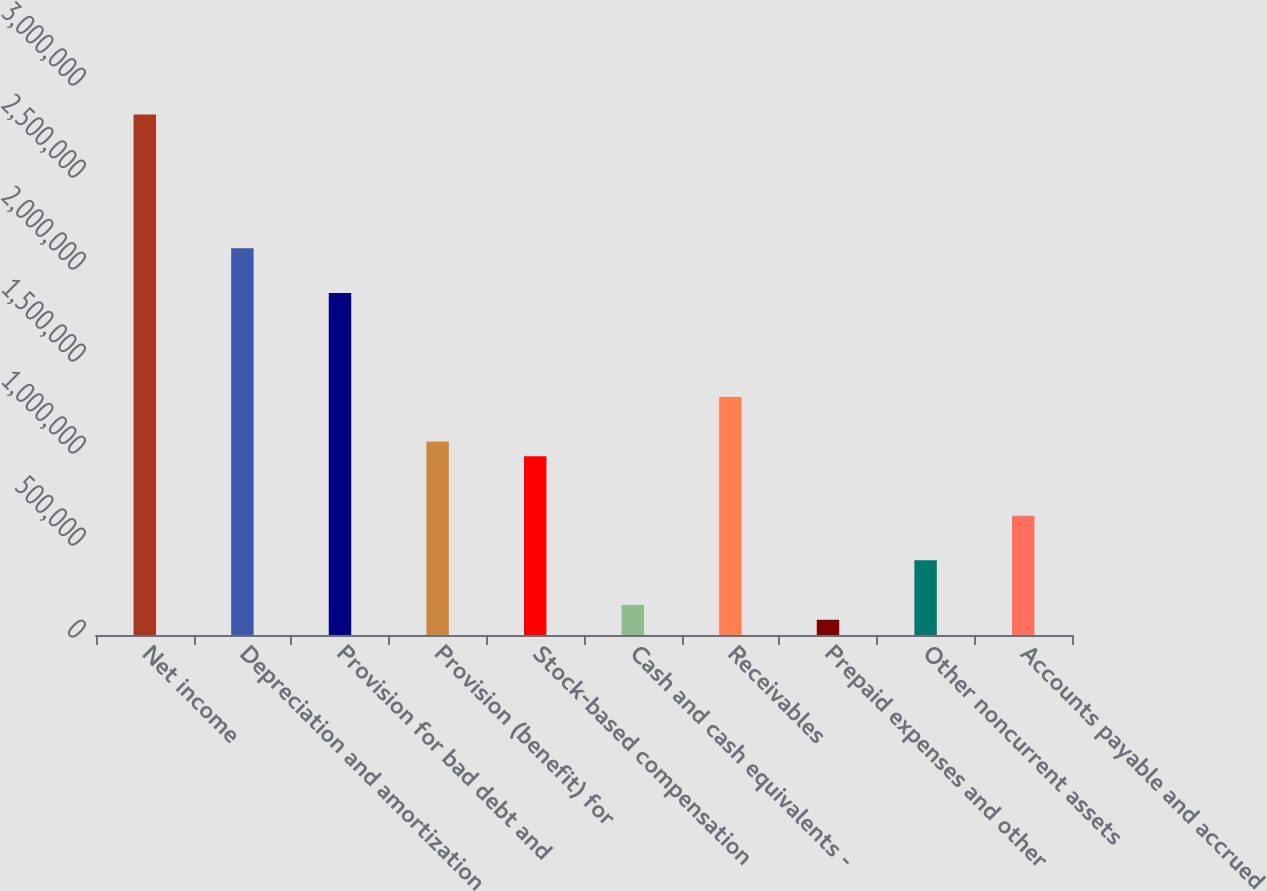Convert chart. <chart><loc_0><loc_0><loc_500><loc_500><bar_chart><fcel>Net income<fcel>Depreciation and amortization<fcel>Provision for bad debt and<fcel>Provision (benefit) for<fcel>Stock-based compensation<fcel>Cash and cash equivalents -<fcel>Receivables<fcel>Prepaid expenses and other<fcel>Other noncurrent assets<fcel>Accounts payable and accrued<nl><fcel>2.82813e+06<fcel>2.10145e+06<fcel>1.85923e+06<fcel>1.05181e+06<fcel>971065<fcel>163646<fcel>1.29403e+06<fcel>82903.9<fcel>405872<fcel>648097<nl></chart> 